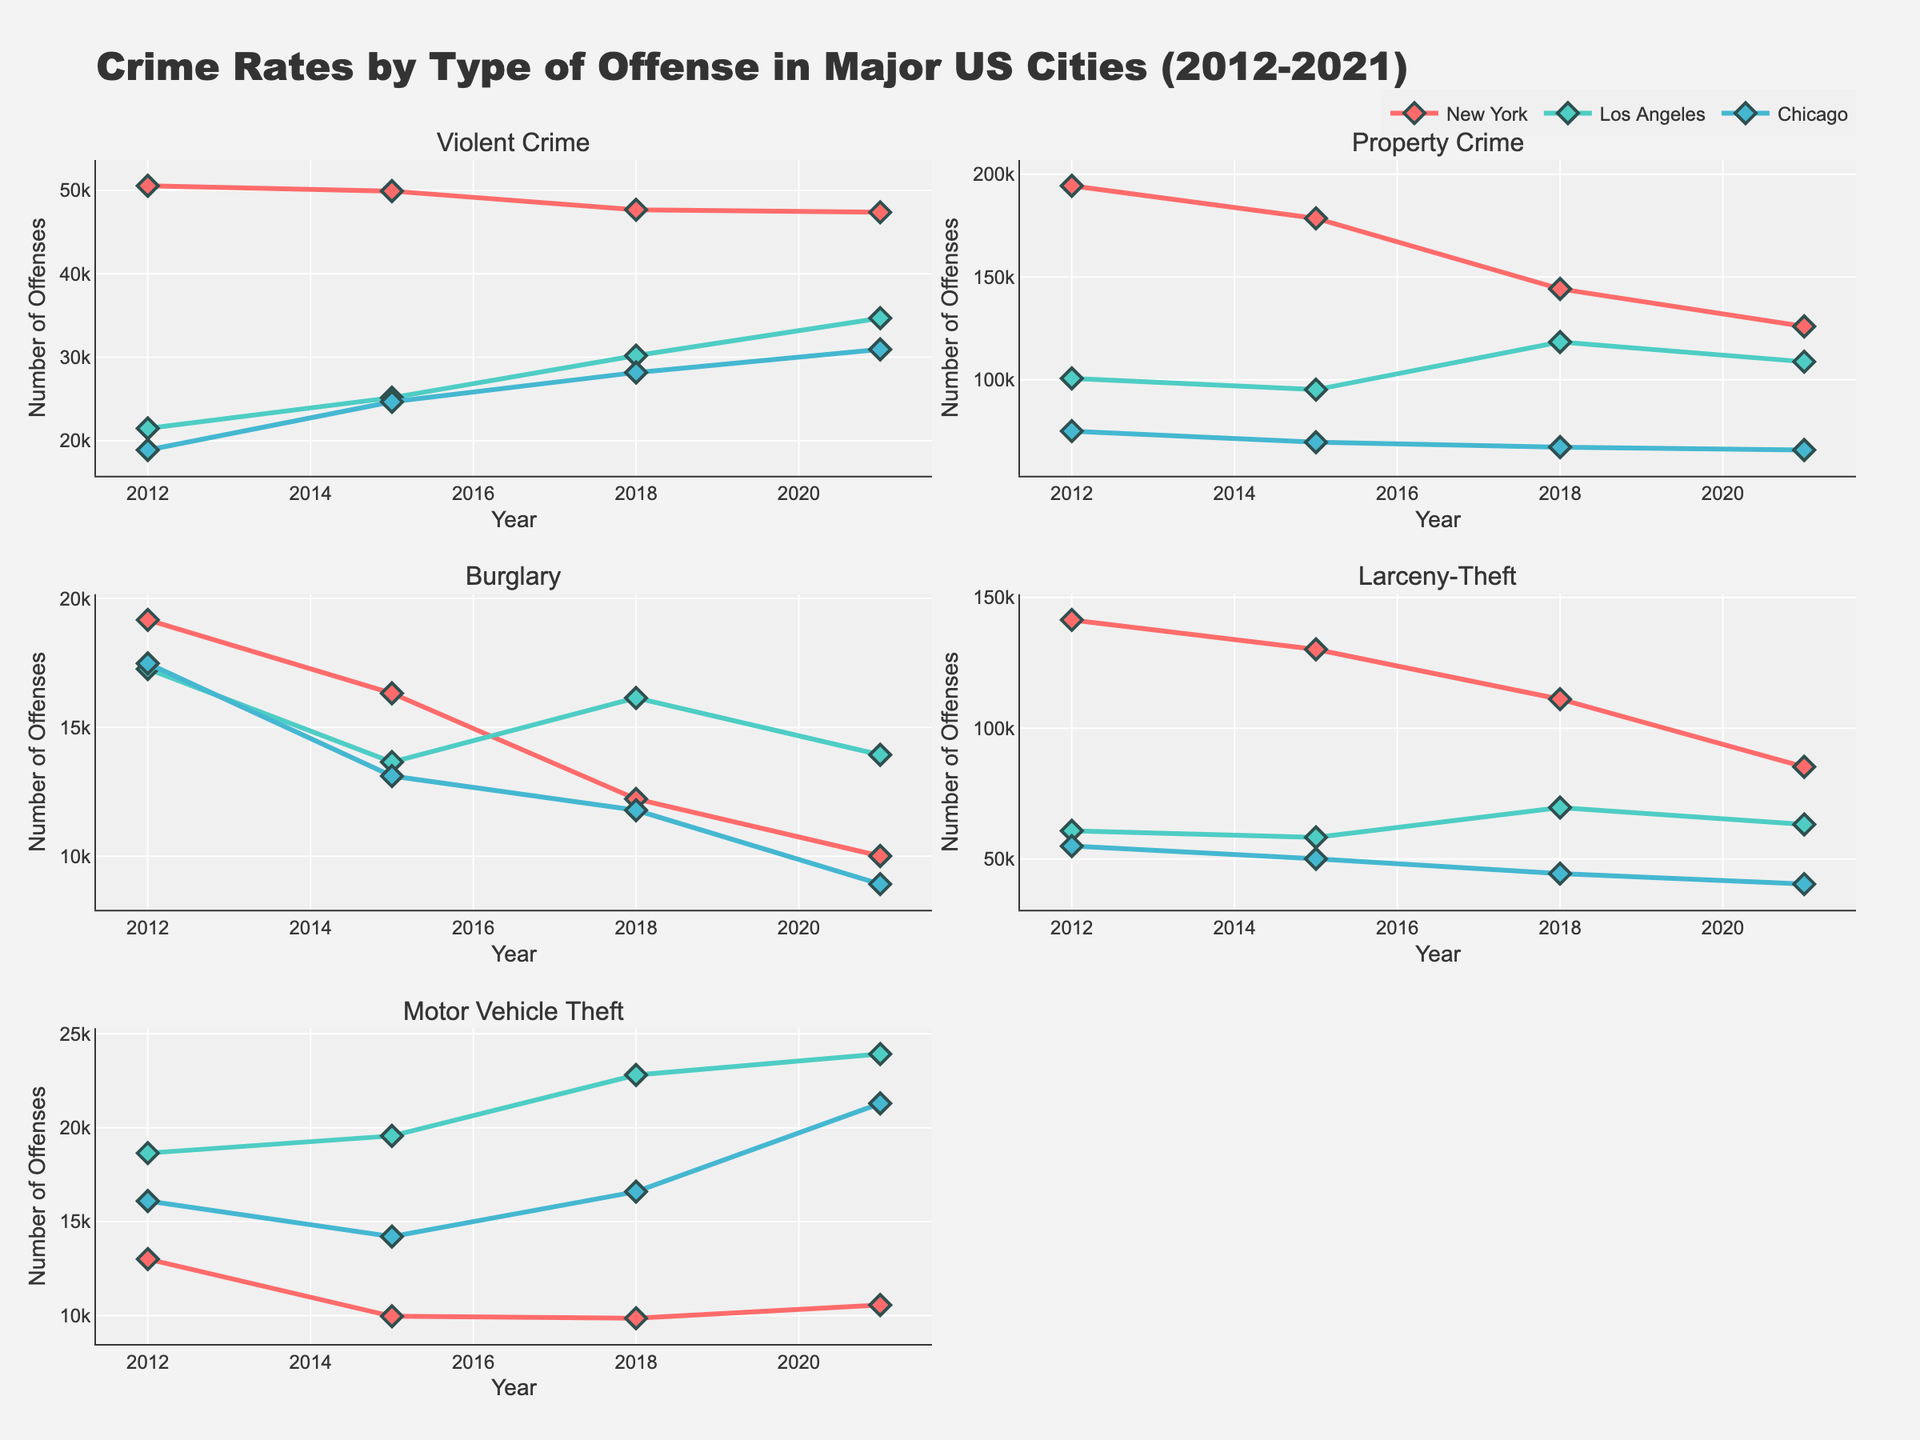How many years of data are displayed in the plot? The plot displays data from 2012, 2015, 2018, and 2021 for each city, which means four different years are covered.
Answer: 4 What is the title of the plot? The title of the plot is located at the top center of the figure.
Answer: "Crime Rates by Type of Offense in Major US Cities (2012-2021)" Which city has the highest number of Violent Crimes in 2021? In the subplot for Violent Crime, observe the points for each city in 2021. The highest point belongs to Chicago.
Answer: Chicago Which type of crime had the largest decrease in incidents in New York from 2012 to 2021? By looking at the subplots for each crime type and focusing on the trend for New York from 2012 to 2021, Burglary shows the largest decrease.
Answer: Burglary Compare the number of Property Crimes in Los Angeles and Chicago in 2018. Which city had fewer incidents? In the Property Crime subplot, compare the values of Los Angeles and Chicago for 2018. Chicago had fewer incidents.
Answer: Chicago What is the average number of Larceny-Theft cases in Los Angeles across the years 2012, 2015, 2018, and 2021? Sum the Larceny-Theft cases for Los Angeles in the years mentioned and divide by 4: (60739 + 58255 + 69656 + 63180) / 4 = 62957.5
Answer: 62957.5 Which city shows a consistent increase in Motor Vehicle Theft cases from 2012 to 2021? By observing the trend lines in the Motor Vehicle Theft subplot, Los Angeles shows a consistent increase.
Answer: Los Angeles By comparing Burglary numbers in 2012 and 2021, which city had the smallest change? In the Burglary subplot, compare the change from 2012 to 2021 for each city. Chicago had the smallest change.
Answer: Chicago Which type of crime had the most varied trends (ups and downs) across the cities over the years? Observe the trends in all subplots and determine which subplot has the most fluctuation in lines for the cities. Larceny-Theft demonstrates the most varied trends.
Answer: Larceny-Theft 